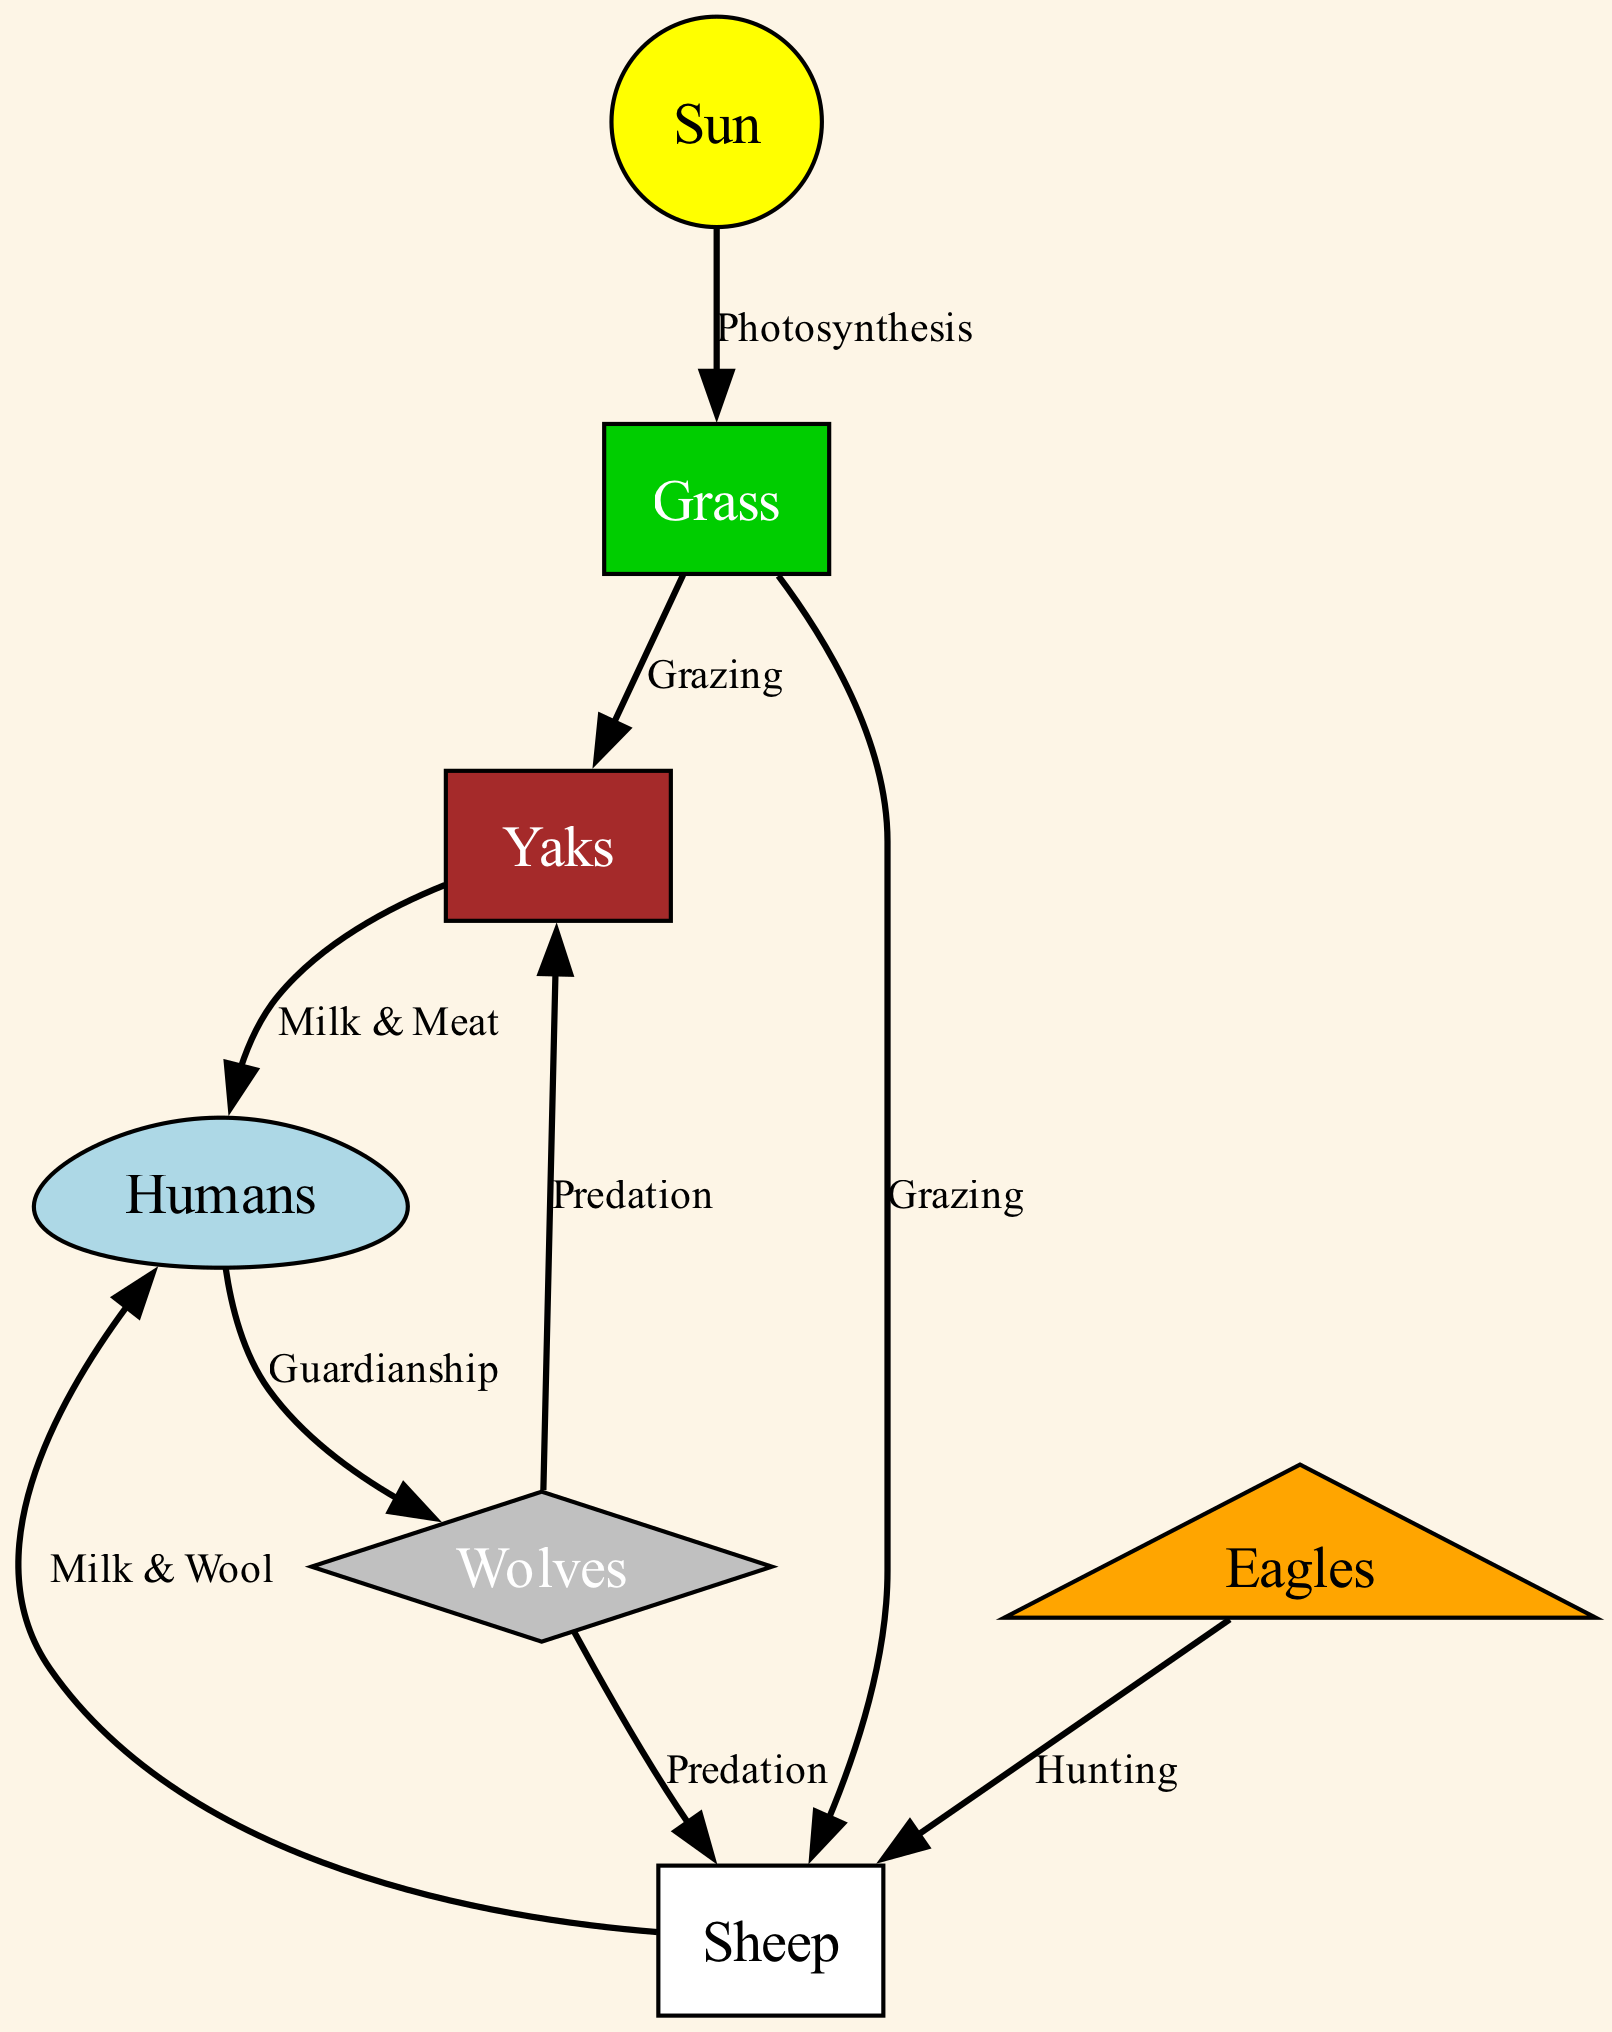What is the primary source of energy in this food chain? The illustration shows that the Sun is represented as the first node and is the initiating element that supports the entire food chain through photosynthesis. The arrows pointing from the Sun to the Grass indicate its fundamental role in providing energy for the subsequent nodes in the diagram.
Answer: Sun How many grazing animals are represented in the diagram? The diagram shows two grazing animals: Yaks and Sheep. Each is connected to Grass, denoting their role in consuming the grass as part of their diet. Counting these nodes gives us the total count of grazing animals in this food chain.
Answer: Two What food source do humans obtain from yaks? The diagram illustrates that humans receive both Milk and Meat from Yaks, indicated by the connection from the Yaks node to the Humans node labeled as such. This shows the resource exchange between these two entities based on their relationship.
Answer: Milk and Meat Which two predators are shown in the diagram? The diagram highlights Wolves and Eagles as the two predators in this food chain. The Wolves are connected to both Yaks and Sheep indicating their predatory behavior, while Eagles are shown hunting Sheep. This shows the diversity of the predation present in this ecosystem.
Answer: Wolves and Eagles What role do humans play in relation to predators? In the diagram, humans are depicted as guardians with a directed edge connecting them to Wolves. This signifies that humans protect their livestock (Yaks and Sheep) from being preyed upon by these predators, emphasizing the guardianship aspect of human involvement in this food chain.
Answer: Guardianship How does grass obtain energy? According to the diagram, grass obtains energy through the process of Photosynthesis, as indicated by the direct connection from the Sun to the Grass. The arrow signifies the energy flow from the Sun to Grass, which is crucial for its growth and sustenance.
Answer: Photosynthesis What do eagles primarily hunt for? The diagram indicates that Eagles primarily hunt Sheep, shown by the directed edge from Eagles to the Sheep labeled as "Hunting". This illustrates the specific predatory behavior of Eagles within this food chain.
Answer: Sheep How is the relationship between Grazing Animals and Grass described? The relationship is described as Grazing, where both Yaks and Sheep consume Grass. Each of these animals has a directed edge pointing from Grass to themselves, highlighting their dependence on this primary food source for survival.
Answer: Grazing 